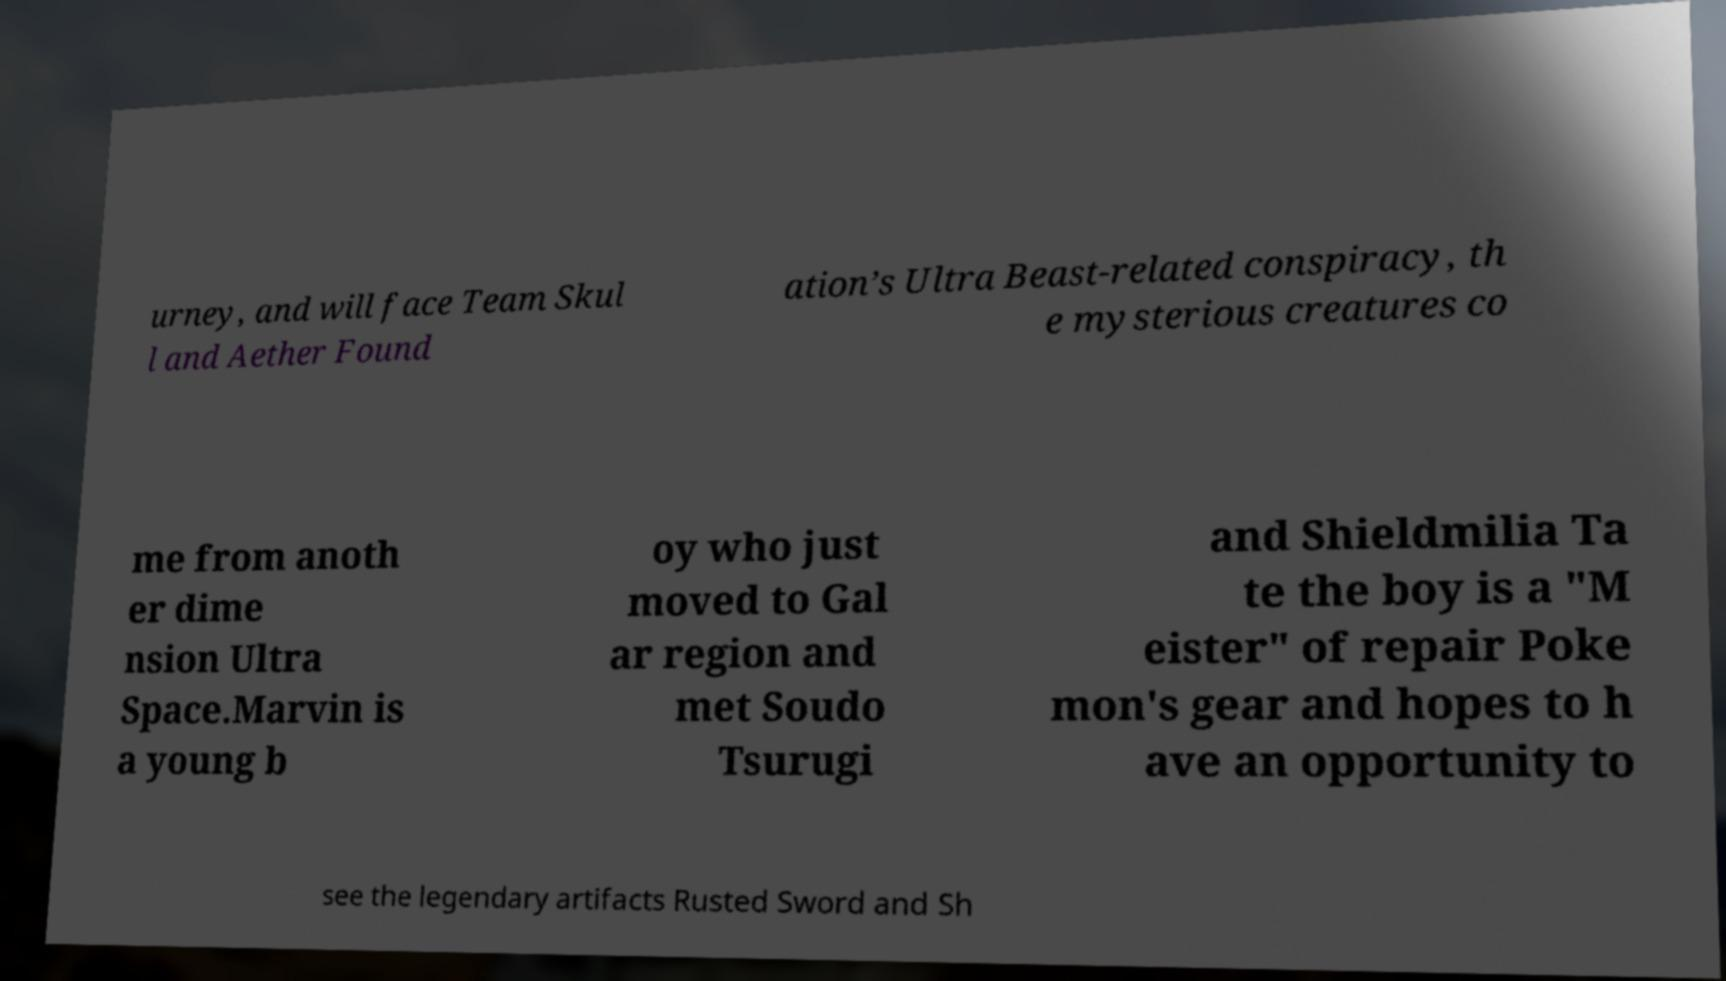What messages or text are displayed in this image? I need them in a readable, typed format. urney, and will face Team Skul l and Aether Found ation’s Ultra Beast-related conspiracy, th e mysterious creatures co me from anoth er dime nsion Ultra Space.Marvin is a young b oy who just moved to Gal ar region and met Soudo Tsurugi and Shieldmilia Ta te the boy is a "M eister" of repair Poke mon's gear and hopes to h ave an opportunity to see the legendary artifacts Rusted Sword and Sh 